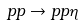Convert formula to latex. <formula><loc_0><loc_0><loc_500><loc_500>p p \rightarrow p p \eta</formula> 